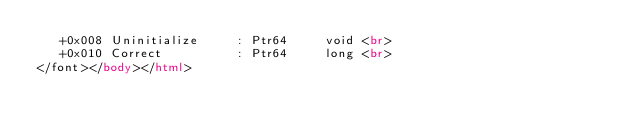<code> <loc_0><loc_0><loc_500><loc_500><_HTML_>   +0x008 Uninitialize     : Ptr64     void <br>
   +0x010 Correct          : Ptr64     long <br>
</font></body></html></code> 